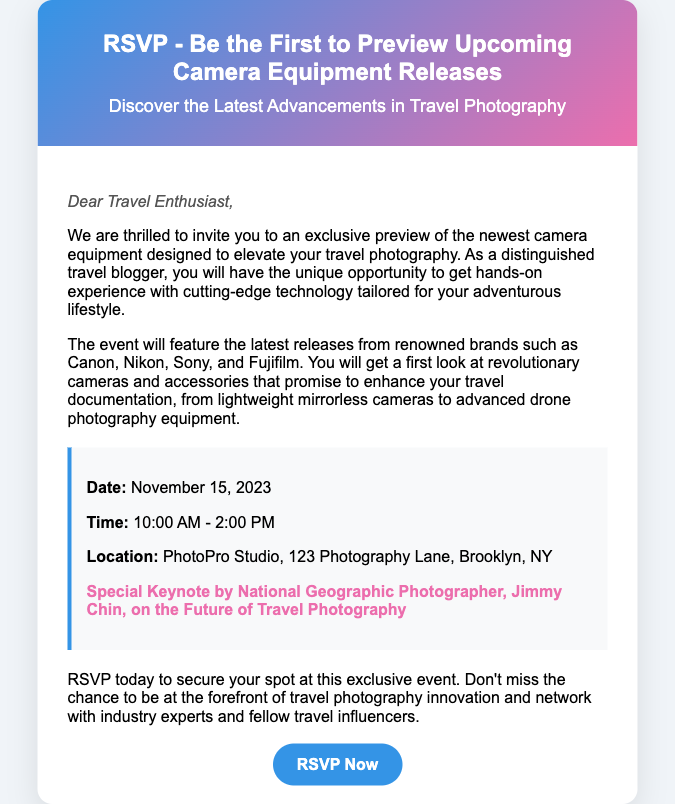What is the event date? The event date is clearly stated in the details section of the document.
Answer: November 15, 2023 What time does the event start? The starting time of the event is specified in the details section.
Answer: 10:00 AM Who is the keynote speaker? The keynote speaker's name is mentioned in the details section, along with their credentials.
Answer: Jimmy Chin Where is the event located? The location of the event is provided in the details section.
Answer: PhotoPro Studio, 123 Photography Lane, Brooklyn, NY What brands will be featured at the event? The document lists several camera brands that will be showcased during the event.
Answer: Canon, Nikon, Sony, Fujifilm What type of photography equipment will be previewed? The document mentions various types of equipment that attendees can expect to see.
Answer: Cameras and accessories Why should someone RSVP? The document explains the benefits of RSVPing as it pertains to the event experience and networking.
Answer: To secure your spot and network with experts What is the target audience for this RSVP event? The introduction of the document specifies the intended audience for the event.
Answer: Travel bloggers What is the main focus of the event? The document highlights the primary theme of the event, which is conveyed in the title and introductory paragraphs.
Answer: Travel photography 